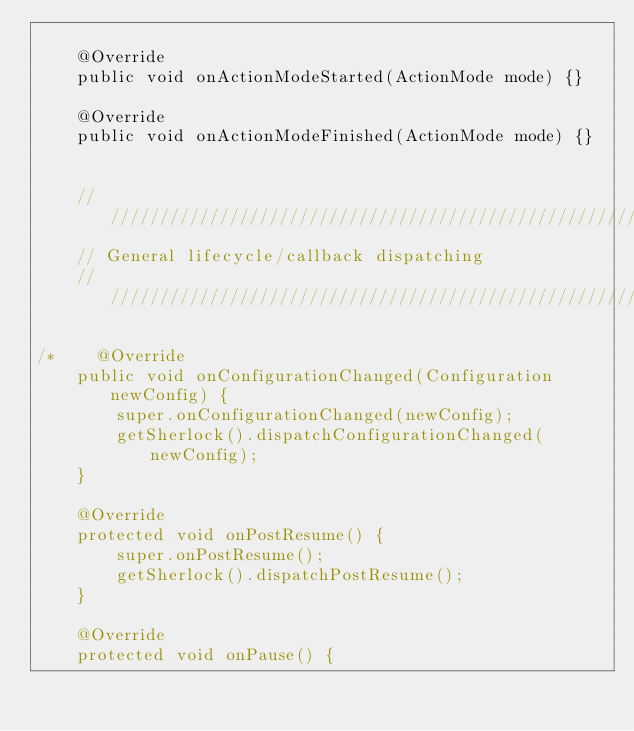<code> <loc_0><loc_0><loc_500><loc_500><_Java_>
    @Override
    public void onActionModeStarted(ActionMode mode) {}

    @Override
    public void onActionModeFinished(ActionMode mode) {}


    ///////////////////////////////////////////////////////////////////////////
    // General lifecycle/callback dispatching
    ///////////////////////////////////////////////////////////////////////////

/*    @Override
    public void onConfigurationChanged(Configuration newConfig) {
        super.onConfigurationChanged(newConfig);
        getSherlock().dispatchConfigurationChanged(newConfig);
    }

    @Override
    protected void onPostResume() {
        super.onPostResume();
        getSherlock().dispatchPostResume();
    }

    @Override
    protected void onPause() {</code> 